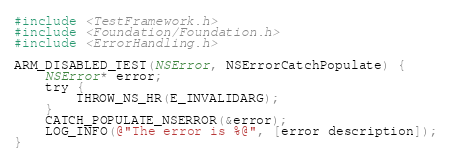<code> <loc_0><loc_0><loc_500><loc_500><_ObjectiveC_>
#include <TestFramework.h>
#include <Foundation/Foundation.h>
#include <ErrorHandling.h>

ARM_DISABLED_TEST(NSError, NSErrorCatchPopulate) {
    NSError* error;
    try {
        THROW_NS_HR(E_INVALIDARG);
    }
    CATCH_POPULATE_NSERROR(&error);
    LOG_INFO(@"The error is %@", [error description]);
}</code> 